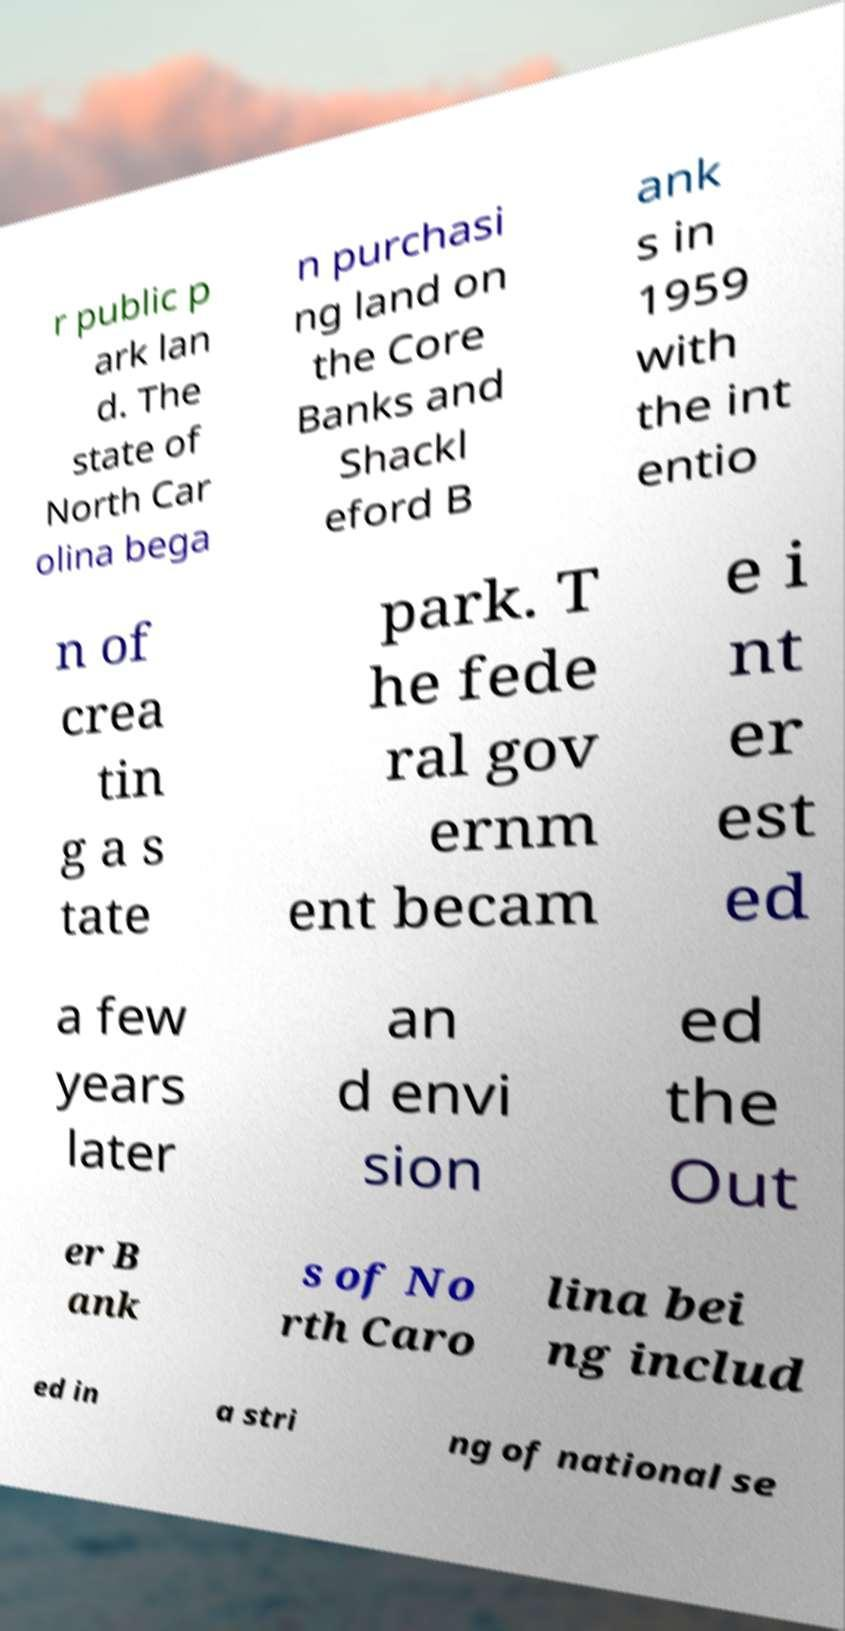Please read and relay the text visible in this image. What does it say? r public p ark lan d. The state of North Car olina bega n purchasi ng land on the Core Banks and Shackl eford B ank s in 1959 with the int entio n of crea tin g a s tate park. T he fede ral gov ernm ent becam e i nt er est ed a few years later an d envi sion ed the Out er B ank s of No rth Caro lina bei ng includ ed in a stri ng of national se 